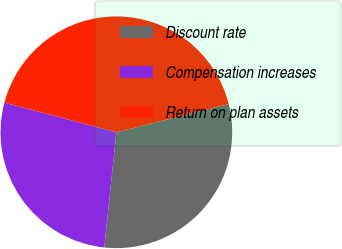Convert chart to OTSL. <chart><loc_0><loc_0><loc_500><loc_500><pie_chart><fcel>Discount rate<fcel>Compensation increases<fcel>Return on plan assets<nl><fcel>30.59%<fcel>27.46%<fcel>41.95%<nl></chart> 